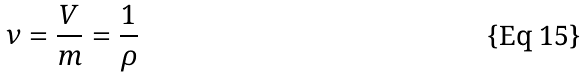<formula> <loc_0><loc_0><loc_500><loc_500>\nu = \frac { V } { m } = \frac { 1 } { \rho }</formula> 